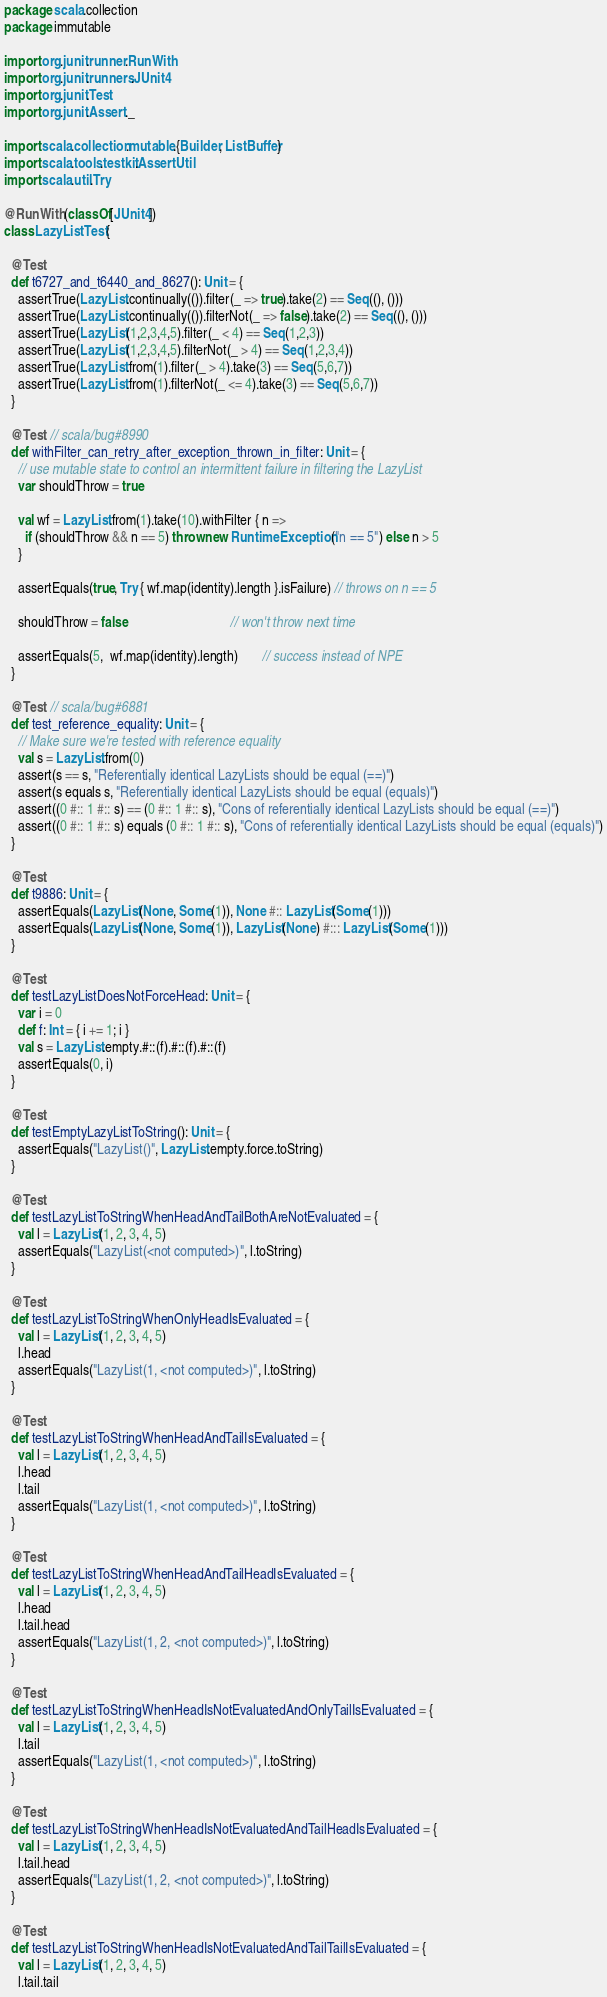<code> <loc_0><loc_0><loc_500><loc_500><_Scala_>package scala.collection
package immutable

import org.junit.runner.RunWith
import org.junit.runners.JUnit4
import org.junit.Test
import org.junit.Assert._

import scala.collection.mutable.{Builder, ListBuffer}
import scala.tools.testkit.AssertUtil
import scala.util.Try

@RunWith(classOf[JUnit4])
class LazyListTest {

  @Test
  def t6727_and_t6440_and_8627(): Unit = {
    assertTrue(LazyList.continually(()).filter(_ => true).take(2) == Seq((), ()))
    assertTrue(LazyList.continually(()).filterNot(_ => false).take(2) == Seq((), ()))
    assertTrue(LazyList(1,2,3,4,5).filter(_ < 4) == Seq(1,2,3))
    assertTrue(LazyList(1,2,3,4,5).filterNot(_ > 4) == Seq(1,2,3,4))
    assertTrue(LazyList.from(1).filter(_ > 4).take(3) == Seq(5,6,7))
    assertTrue(LazyList.from(1).filterNot(_ <= 4).take(3) == Seq(5,6,7))
  }

  @Test // scala/bug#8990
  def withFilter_can_retry_after_exception_thrown_in_filter: Unit = {
    // use mutable state to control an intermittent failure in filtering the LazyList
    var shouldThrow = true

    val wf = LazyList.from(1).take(10).withFilter { n =>
      if (shouldThrow && n == 5) throw new RuntimeException("n == 5") else n > 5
    }

    assertEquals(true, Try { wf.map(identity).length }.isFailure) // throws on n == 5

    shouldThrow = false                              // won't throw next time

    assertEquals(5,  wf.map(identity).length)       // success instead of NPE
  }

  @Test // scala/bug#6881
  def test_reference_equality: Unit = {
    // Make sure we're tested with reference equality
    val s = LazyList.from(0)
    assert(s == s, "Referentially identical LazyLists should be equal (==)")
    assert(s equals s, "Referentially identical LazyLists should be equal (equals)")
    assert((0 #:: 1 #:: s) == (0 #:: 1 #:: s), "Cons of referentially identical LazyLists should be equal (==)")
    assert((0 #:: 1 #:: s) equals (0 #:: 1 #:: s), "Cons of referentially identical LazyLists should be equal (equals)")
  }

  @Test
  def t9886: Unit = {
    assertEquals(LazyList(None, Some(1)), None #:: LazyList(Some(1)))
    assertEquals(LazyList(None, Some(1)), LazyList(None) #::: LazyList(Some(1)))
  }

  @Test
  def testLazyListDoesNotForceHead: Unit = {
    var i = 0
    def f: Int = { i += 1; i }
    val s = LazyList.empty.#::(f).#::(f).#::(f)
    assertEquals(0, i)
  }

  @Test
  def testEmptyLazyListToString(): Unit = {
    assertEquals("LazyList()", LazyList.empty.force.toString)
  }

  @Test
  def testLazyListToStringWhenHeadAndTailBothAreNotEvaluated = {
    val l = LazyList(1, 2, 3, 4, 5)
    assertEquals("LazyList(<not computed>)", l.toString)
  }

  @Test
  def testLazyListToStringWhenOnlyHeadIsEvaluated = {
    val l = LazyList(1, 2, 3, 4, 5)
    l.head
    assertEquals("LazyList(1, <not computed>)", l.toString)
  }

  @Test
  def testLazyListToStringWhenHeadAndTailIsEvaluated = {
    val l = LazyList(1, 2, 3, 4, 5)
    l.head
    l.tail
    assertEquals("LazyList(1, <not computed>)", l.toString)
  }

  @Test
  def testLazyListToStringWhenHeadAndTailHeadIsEvaluated = {
    val l = LazyList(1, 2, 3, 4, 5)
    l.head
    l.tail.head
    assertEquals("LazyList(1, 2, <not computed>)", l.toString)
  }

  @Test
  def testLazyListToStringWhenHeadIsNotEvaluatedAndOnlyTailIsEvaluated = {
    val l = LazyList(1, 2, 3, 4, 5)
    l.tail
    assertEquals("LazyList(1, <not computed>)", l.toString)
  }

  @Test
  def testLazyListToStringWhenHeadIsNotEvaluatedAndTailHeadIsEvaluated = {
    val l = LazyList(1, 2, 3, 4, 5)
    l.tail.head
    assertEquals("LazyList(1, 2, <not computed>)", l.toString)
  }

  @Test
  def testLazyListToStringWhenHeadIsNotEvaluatedAndTailTailIsEvaluated = {
    val l = LazyList(1, 2, 3, 4, 5)
    l.tail.tail</code> 